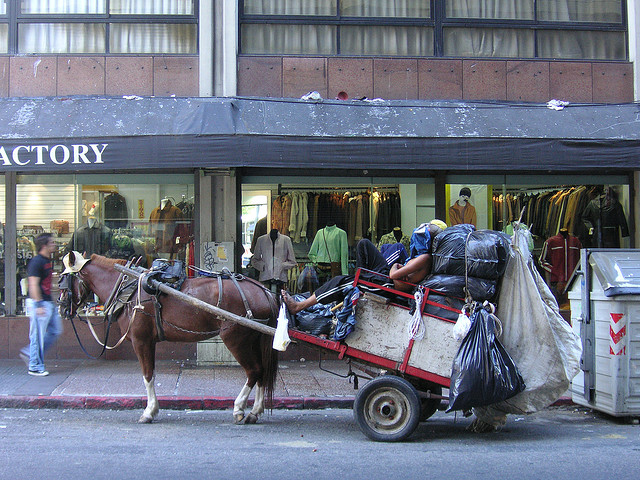Please extract the text content from this image. ACTORY 